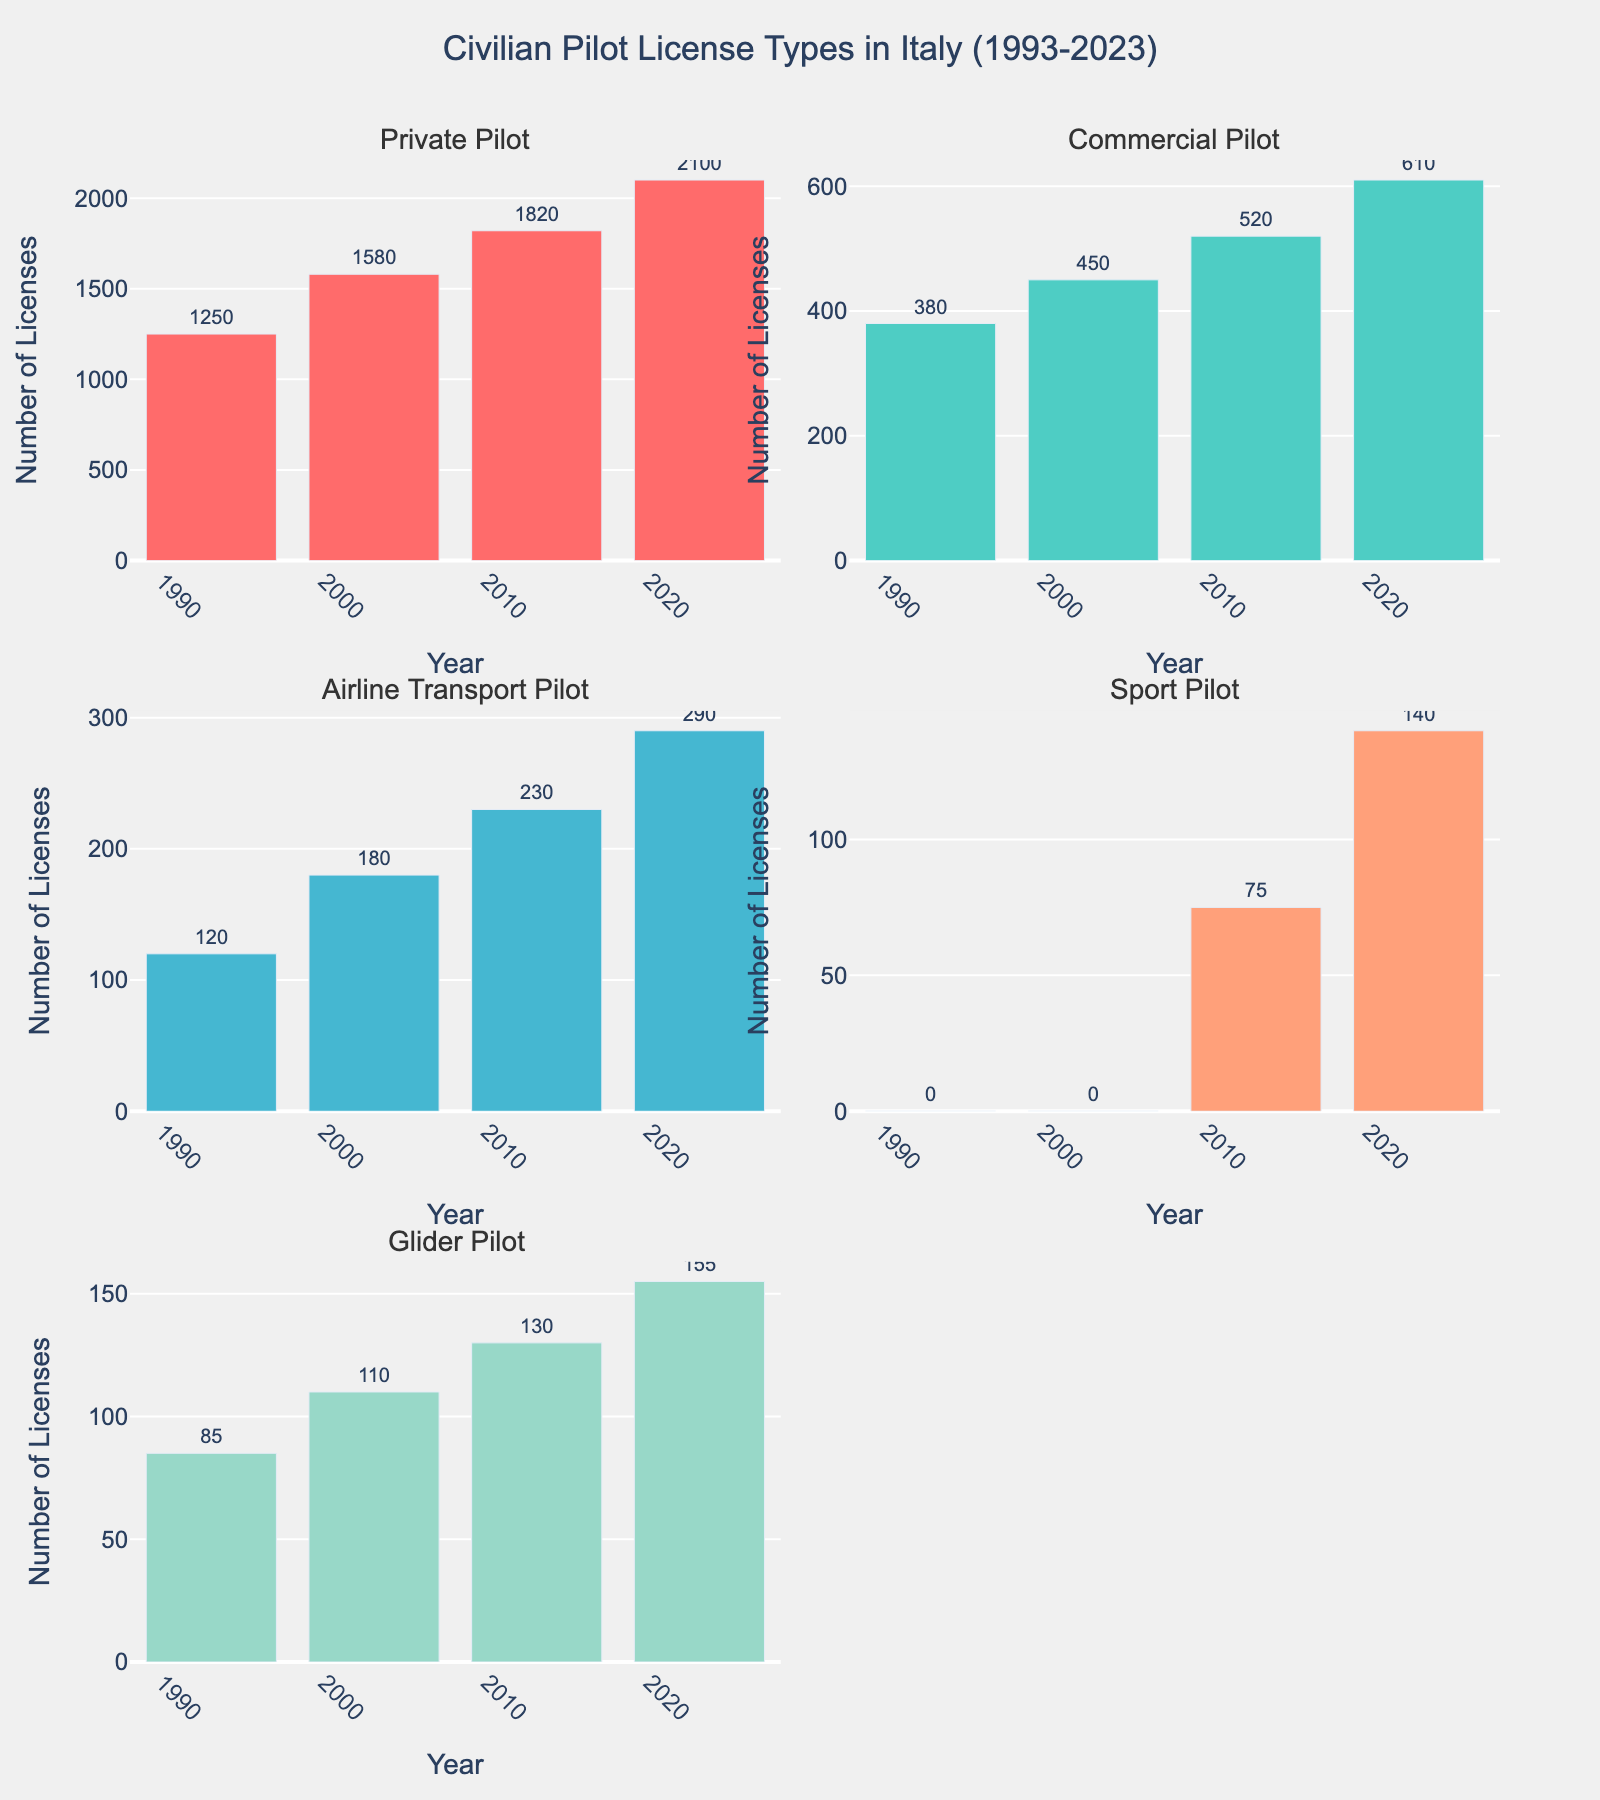Which year saw the highest number of Private Pilot licenses issued? The subplot for Private Pilot licenses shows the highest bar in the year 2023.
Answer: 2023 How many Airline Transport Pilot licenses were issued in 2003? Refer to the subplot for the Airline Transport Pilot licenses. The bar for 2003 reaches up to 180 licenses.
Answer: 180 What is the difference in the number of Commercial Pilot licenses issued between 1993 and 2023? In the subplot for Commercial Pilot licenses, the bar for 1993 is at 380 and for 2023 is at 610. So, the difference is 610 - 380.
Answer: 230 Which license type had zero issuances in 1993 and 2003? The subplot for Sport Pilot licenses shows no bar for both 1993 and 2003, indicating zero issuances.
Answer: Sport Pilot How many Glider Pilot licenses were issued in total over the 30 years? Summing the values in the Glider Pilot subplot: 85 + 110 + 130 + 155 = 480.
Answer: 480 What is the overall trend in the number of Private Pilot licenses issued from 1993 to 2023? The Private Pilot subplot shows bars increasing steadily from 1250 in 1993 to 2100 in 2023, indicating a rising trend.
Answer: Increasing Which license type had the least number issued in 2023? In 2023, the subplot for Airline Transport Pilot licenses shows the smallest bar at 140.
Answer: Airline Transport Pilot By how much did the number of Sport Pilot licenses increase from 2013 to 2023? The Sport Pilot subplot shows bars at 75 for 2013 and at 140 for 2023. The increase is 140 - 75.
Answer: 65 In which year were the fewest number of Glider Pilot licenses issued? The Glider Pilot subplot shows the lowest bar in 1993, which represents 85 licenses.
Answer: 1993 Compare the total number of Private Pilot and Commercial Pilot licenses issued over the 30 years. Which is greater? Summing the values for Private Pilot: 1250 + 1580 + 1820 + 2100 = 6750, and for Commercial Pilot: 380 + 450 + 520 + 610 = 1960. The total for Private Pilot is greater.
Answer: Private Pilot 